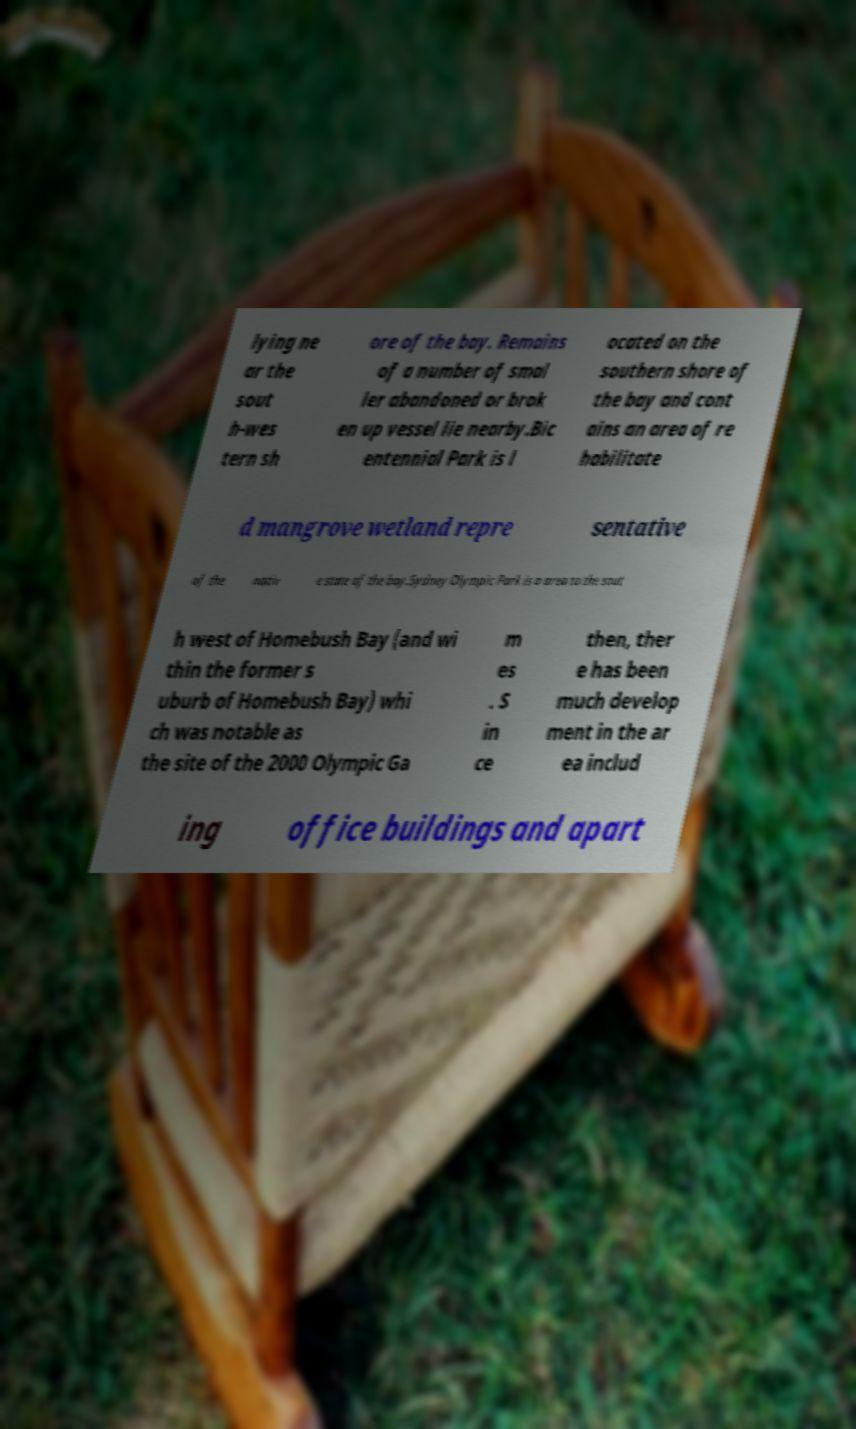What messages or text are displayed in this image? I need them in a readable, typed format. lying ne ar the sout h-wes tern sh ore of the bay. Remains of a number of smal ler abandoned or brok en up vessel lie nearby.Bic entennial Park is l ocated on the southern shore of the bay and cont ains an area of re habilitate d mangrove wetland repre sentative of the nativ e state of the bay.Sydney Olympic Park is a area to the sout h west of Homebush Bay (and wi thin the former s uburb of Homebush Bay) whi ch was notable as the site of the 2000 Olympic Ga m es . S in ce then, ther e has been much develop ment in the ar ea includ ing office buildings and apart 